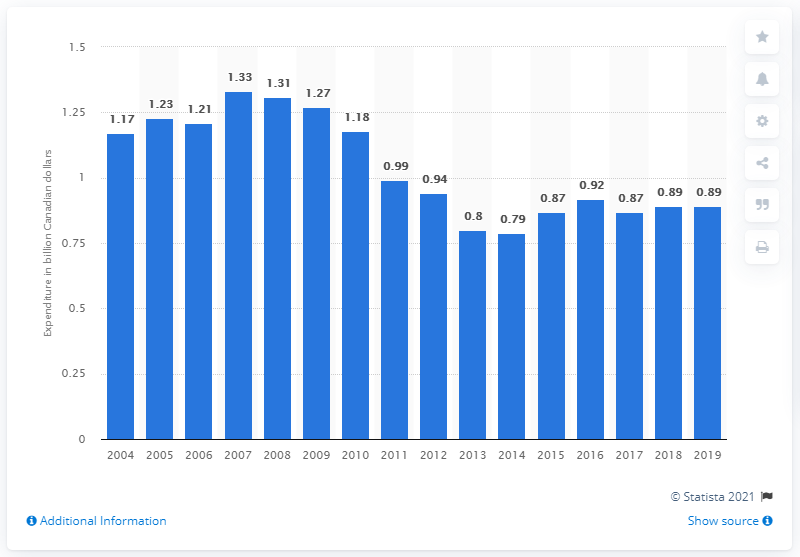Point out several critical features in this image. In 2007, the pharmaceutical industry in Canada recorded the highest amount of research and development spending. 